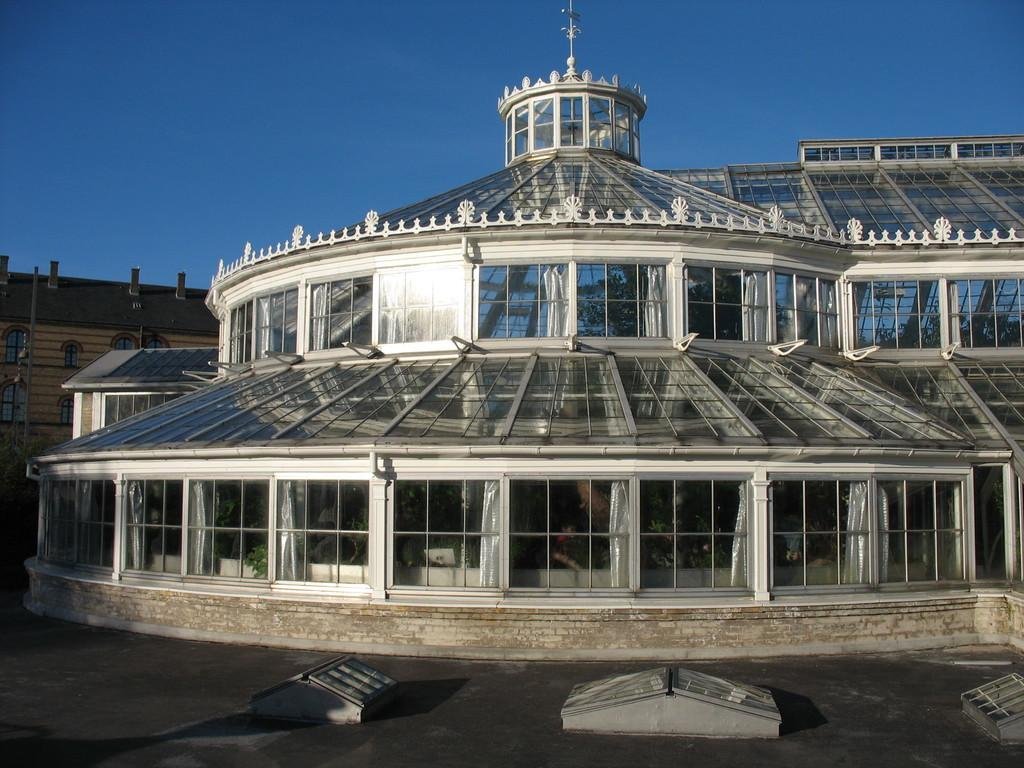What is the color of the road in the image? The road in the image is black. What type of building can be seen in the image? There is a building with glass windows in the image. Can you describe another building in the image? There is another building with a brown color rooftop in the image. What type of vegetation is on the left side of the image? Trees are present on the left side of the image. What type of attention is the building with glass windows receiving in the image? There is no indication in the image that the building with glass windows is receiving any specific type of attention. Is there a record player visible in the image? There is no record player present in the image. 